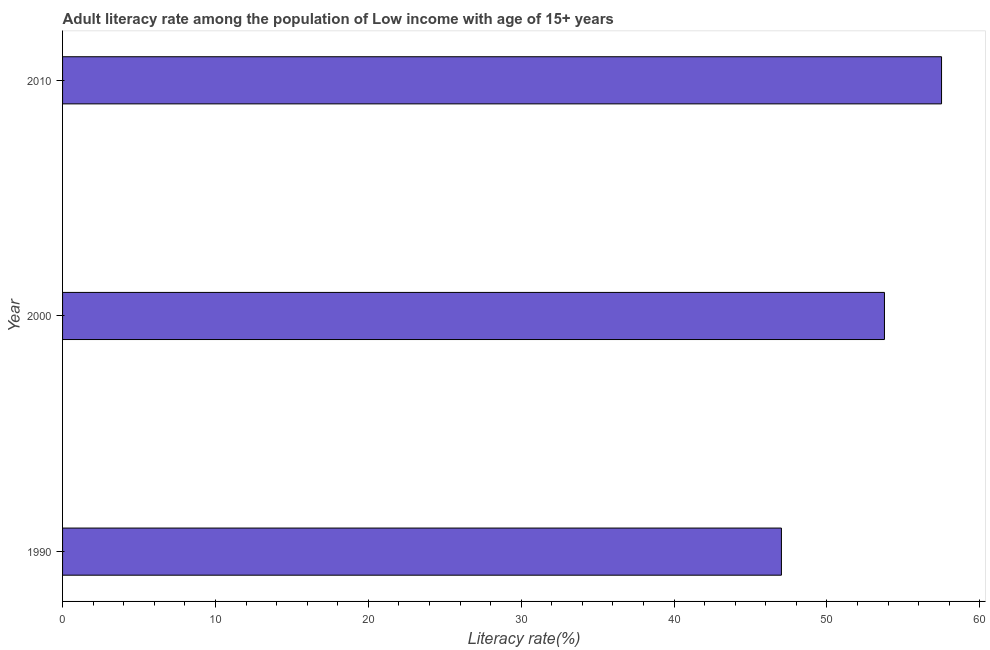Does the graph contain any zero values?
Give a very brief answer. No. Does the graph contain grids?
Provide a succinct answer. No. What is the title of the graph?
Your answer should be very brief. Adult literacy rate among the population of Low income with age of 15+ years. What is the label or title of the X-axis?
Your answer should be compact. Literacy rate(%). What is the label or title of the Y-axis?
Make the answer very short. Year. What is the adult literacy rate in 2010?
Your answer should be very brief. 57.5. Across all years, what is the maximum adult literacy rate?
Your answer should be very brief. 57.5. Across all years, what is the minimum adult literacy rate?
Make the answer very short. 47.02. In which year was the adult literacy rate maximum?
Provide a succinct answer. 2010. In which year was the adult literacy rate minimum?
Ensure brevity in your answer.  1990. What is the sum of the adult literacy rate?
Offer a very short reply. 158.28. What is the difference between the adult literacy rate in 1990 and 2010?
Offer a very short reply. -10.47. What is the average adult literacy rate per year?
Make the answer very short. 52.76. What is the median adult literacy rate?
Your response must be concise. 53.76. In how many years, is the adult literacy rate greater than 18 %?
Provide a succinct answer. 3. Do a majority of the years between 1990 and 2010 (inclusive) have adult literacy rate greater than 38 %?
Your response must be concise. Yes. What is the ratio of the adult literacy rate in 1990 to that in 2010?
Make the answer very short. 0.82. Is the adult literacy rate in 2000 less than that in 2010?
Your response must be concise. Yes. Is the difference between the adult literacy rate in 1990 and 2000 greater than the difference between any two years?
Your response must be concise. No. What is the difference between the highest and the second highest adult literacy rate?
Your answer should be compact. 3.73. Is the sum of the adult literacy rate in 2000 and 2010 greater than the maximum adult literacy rate across all years?
Provide a succinct answer. Yes. What is the difference between the highest and the lowest adult literacy rate?
Offer a very short reply. 10.47. How many bars are there?
Your response must be concise. 3. What is the Literacy rate(%) in 1990?
Keep it short and to the point. 47.02. What is the Literacy rate(%) of 2000?
Provide a short and direct response. 53.76. What is the Literacy rate(%) of 2010?
Your answer should be compact. 57.5. What is the difference between the Literacy rate(%) in 1990 and 2000?
Provide a succinct answer. -6.74. What is the difference between the Literacy rate(%) in 1990 and 2010?
Offer a very short reply. -10.47. What is the difference between the Literacy rate(%) in 2000 and 2010?
Provide a short and direct response. -3.73. What is the ratio of the Literacy rate(%) in 1990 to that in 2000?
Your answer should be very brief. 0.88. What is the ratio of the Literacy rate(%) in 1990 to that in 2010?
Give a very brief answer. 0.82. What is the ratio of the Literacy rate(%) in 2000 to that in 2010?
Offer a terse response. 0.94. 